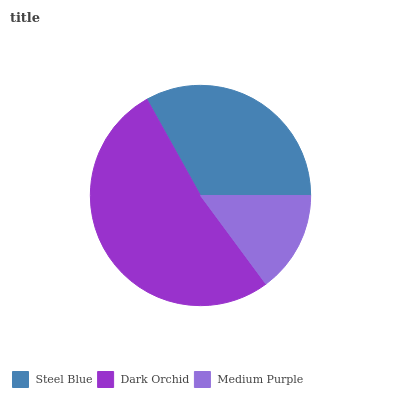Is Medium Purple the minimum?
Answer yes or no. Yes. Is Dark Orchid the maximum?
Answer yes or no. Yes. Is Dark Orchid the minimum?
Answer yes or no. No. Is Medium Purple the maximum?
Answer yes or no. No. Is Dark Orchid greater than Medium Purple?
Answer yes or no. Yes. Is Medium Purple less than Dark Orchid?
Answer yes or no. Yes. Is Medium Purple greater than Dark Orchid?
Answer yes or no. No. Is Dark Orchid less than Medium Purple?
Answer yes or no. No. Is Steel Blue the high median?
Answer yes or no. Yes. Is Steel Blue the low median?
Answer yes or no. Yes. Is Dark Orchid the high median?
Answer yes or no. No. Is Dark Orchid the low median?
Answer yes or no. No. 